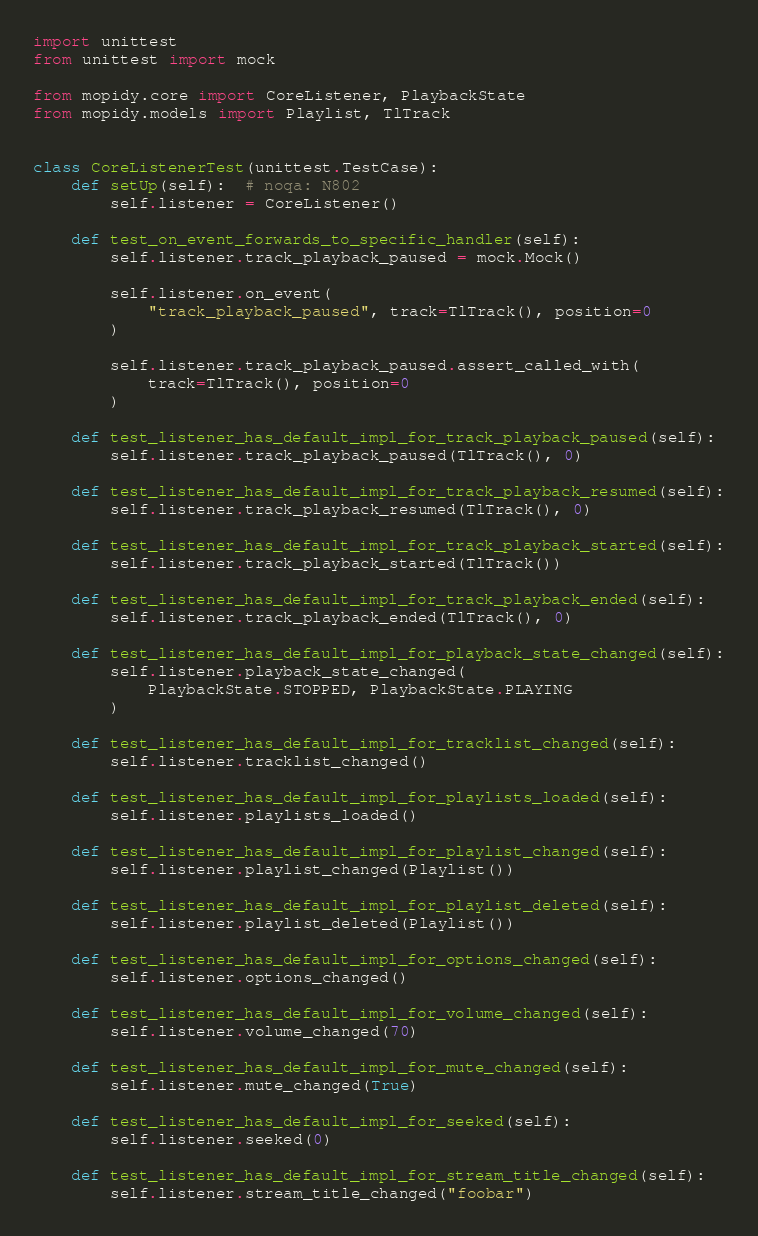Convert code to text. <code><loc_0><loc_0><loc_500><loc_500><_Python_>import unittest
from unittest import mock

from mopidy.core import CoreListener, PlaybackState
from mopidy.models import Playlist, TlTrack


class CoreListenerTest(unittest.TestCase):
    def setUp(self):  # noqa: N802
        self.listener = CoreListener()

    def test_on_event_forwards_to_specific_handler(self):
        self.listener.track_playback_paused = mock.Mock()

        self.listener.on_event(
            "track_playback_paused", track=TlTrack(), position=0
        )

        self.listener.track_playback_paused.assert_called_with(
            track=TlTrack(), position=0
        )

    def test_listener_has_default_impl_for_track_playback_paused(self):
        self.listener.track_playback_paused(TlTrack(), 0)

    def test_listener_has_default_impl_for_track_playback_resumed(self):
        self.listener.track_playback_resumed(TlTrack(), 0)

    def test_listener_has_default_impl_for_track_playback_started(self):
        self.listener.track_playback_started(TlTrack())

    def test_listener_has_default_impl_for_track_playback_ended(self):
        self.listener.track_playback_ended(TlTrack(), 0)

    def test_listener_has_default_impl_for_playback_state_changed(self):
        self.listener.playback_state_changed(
            PlaybackState.STOPPED, PlaybackState.PLAYING
        )

    def test_listener_has_default_impl_for_tracklist_changed(self):
        self.listener.tracklist_changed()

    def test_listener_has_default_impl_for_playlists_loaded(self):
        self.listener.playlists_loaded()

    def test_listener_has_default_impl_for_playlist_changed(self):
        self.listener.playlist_changed(Playlist())

    def test_listener_has_default_impl_for_playlist_deleted(self):
        self.listener.playlist_deleted(Playlist())

    def test_listener_has_default_impl_for_options_changed(self):
        self.listener.options_changed()

    def test_listener_has_default_impl_for_volume_changed(self):
        self.listener.volume_changed(70)

    def test_listener_has_default_impl_for_mute_changed(self):
        self.listener.mute_changed(True)

    def test_listener_has_default_impl_for_seeked(self):
        self.listener.seeked(0)

    def test_listener_has_default_impl_for_stream_title_changed(self):
        self.listener.stream_title_changed("foobar")
</code> 